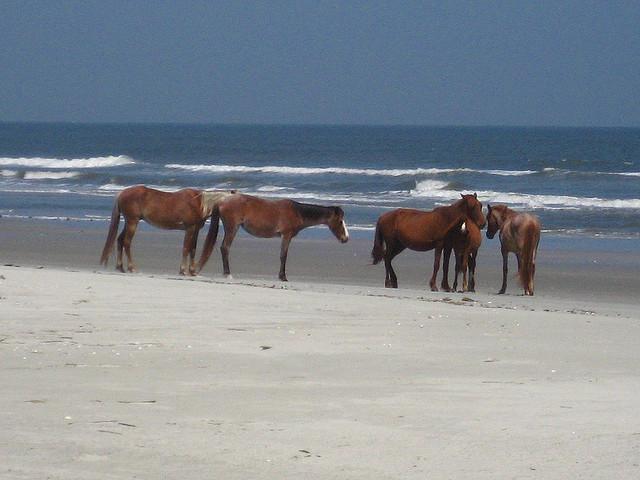Are there any boats in the water?
Answer briefly. No. What are the horses standing on?
Write a very short answer. Sand. Are the horses going in the same direction?
Answer briefly. No. Do all of the horses have saddles on?
Short answer required. No. Are these horses wild?
Give a very brief answer. Yes. 